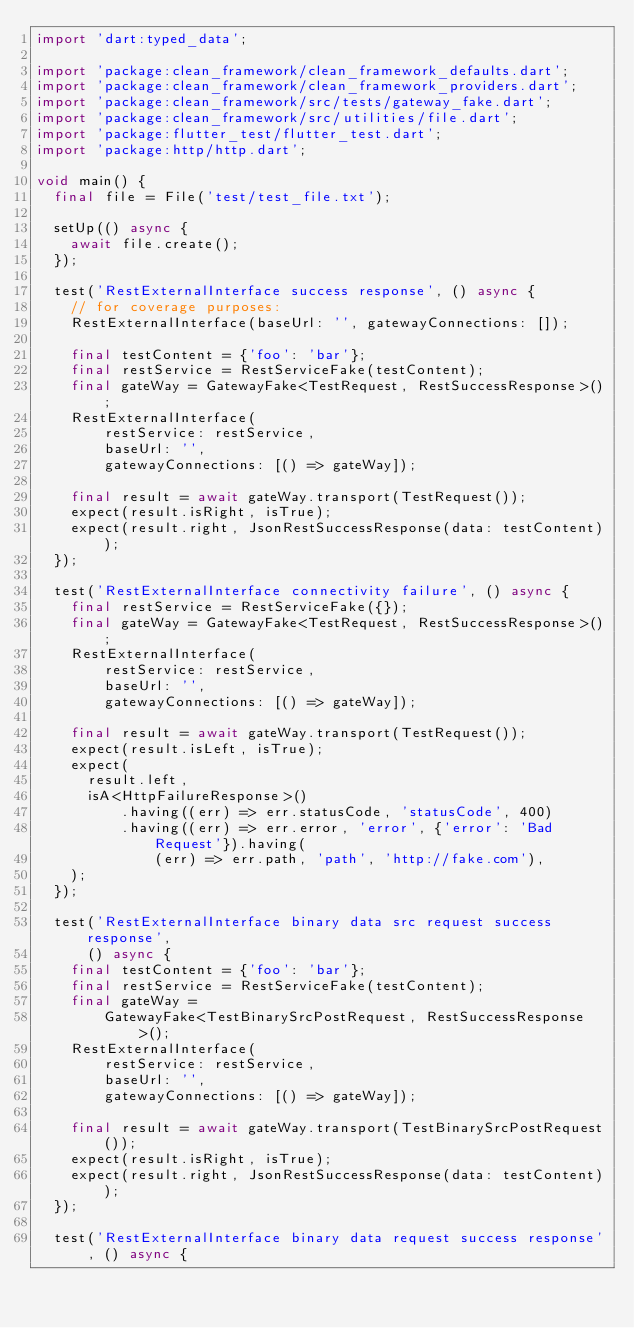<code> <loc_0><loc_0><loc_500><loc_500><_Dart_>import 'dart:typed_data';

import 'package:clean_framework/clean_framework_defaults.dart';
import 'package:clean_framework/clean_framework_providers.dart';
import 'package:clean_framework/src/tests/gateway_fake.dart';
import 'package:clean_framework/src/utilities/file.dart';
import 'package:flutter_test/flutter_test.dart';
import 'package:http/http.dart';

void main() {
  final file = File('test/test_file.txt');

  setUp(() async {
    await file.create();
  });

  test('RestExternalInterface success response', () async {
    // for coverage purposes:
    RestExternalInterface(baseUrl: '', gatewayConnections: []);

    final testContent = {'foo': 'bar'};
    final restService = RestServiceFake(testContent);
    final gateWay = GatewayFake<TestRequest, RestSuccessResponse>();
    RestExternalInterface(
        restService: restService,
        baseUrl: '',
        gatewayConnections: [() => gateWay]);

    final result = await gateWay.transport(TestRequest());
    expect(result.isRight, isTrue);
    expect(result.right, JsonRestSuccessResponse(data: testContent));
  });

  test('RestExternalInterface connectivity failure', () async {
    final restService = RestServiceFake({});
    final gateWay = GatewayFake<TestRequest, RestSuccessResponse>();
    RestExternalInterface(
        restService: restService,
        baseUrl: '',
        gatewayConnections: [() => gateWay]);

    final result = await gateWay.transport(TestRequest());
    expect(result.isLeft, isTrue);
    expect(
      result.left,
      isA<HttpFailureResponse>()
          .having((err) => err.statusCode, 'statusCode', 400)
          .having((err) => err.error, 'error', {'error': 'Bad Request'}).having(
              (err) => err.path, 'path', 'http://fake.com'),
    );
  });

  test('RestExternalInterface binary data src request success response',
      () async {
    final testContent = {'foo': 'bar'};
    final restService = RestServiceFake(testContent);
    final gateWay =
        GatewayFake<TestBinarySrcPostRequest, RestSuccessResponse>();
    RestExternalInterface(
        restService: restService,
        baseUrl: '',
        gatewayConnections: [() => gateWay]);

    final result = await gateWay.transport(TestBinarySrcPostRequest());
    expect(result.isRight, isTrue);
    expect(result.right, JsonRestSuccessResponse(data: testContent));
  });

  test('RestExternalInterface binary data request success response', () async {</code> 